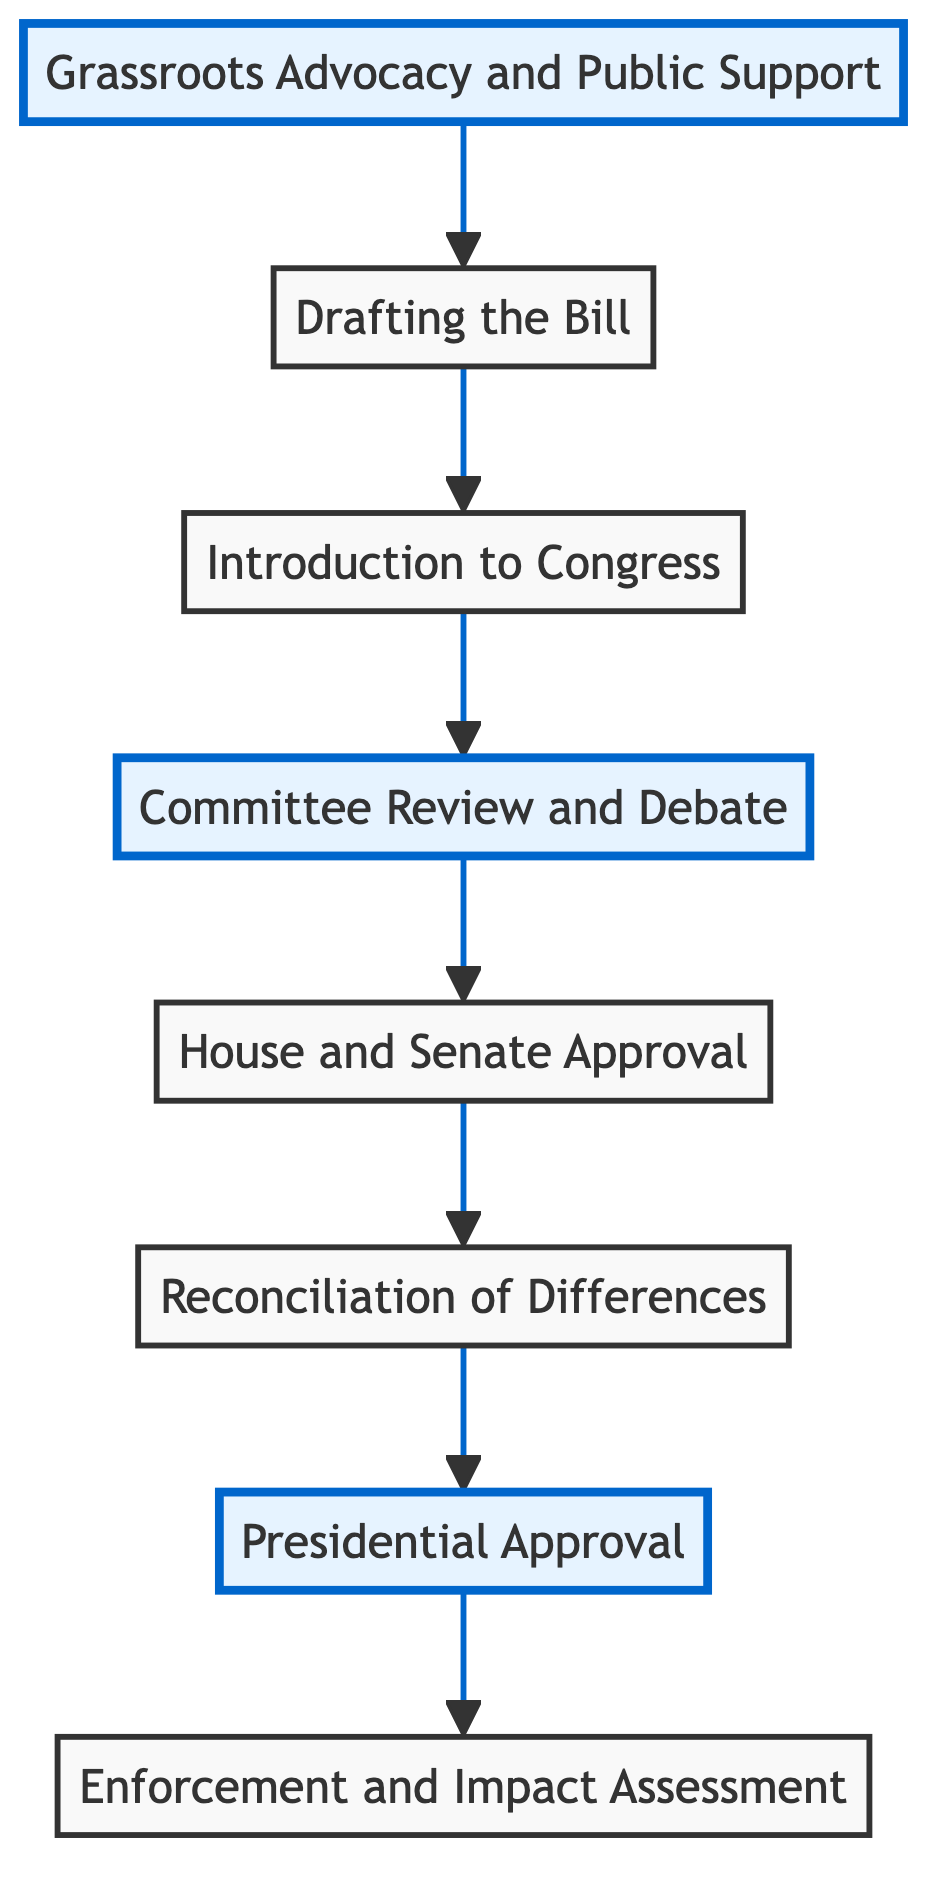What is the first step in the journey of legislation? The first step is identified as "Grassroots Advocacy and Public Support," which refers to the initial movements and efforts made by conservative groups to advocate for policy changes.
Answer: Grassroots Advocacy and Public Support Which entity drafts the proposed legislation? According to the diagram, conservative lawmakers, often influenced by think tanks, work with legal experts to draft the bill, indicating that legislators are primarily responsible for this step.
Answer: Conservative lawmakers What happens after the bill is drafted? The next step after drafting is the "Introduction to Congress," which involves a conservative member presenting the bill in either the House or Senate.
Answer: Introduction to Congress How many main steps are there in the journey of conservative legislation? Count all the steps listed in the diagram: there are eight main steps from "Grassroots Advocacy and Public Support" to "Enforcement and Impact Assessment."
Answer: Eight What is the main goal of the committee review and debate? The primary goal in the "Committee Review and Debate" stage is to review, amend, and ensure the bill aligns with conservative values through discussions among committee members.
Answer: Align the bill with conservative principles What occurs if there are differences between the House and Senate versions of the bill? The diagram states that a "conference committee is formed" to reconcile the differences, indicating a collaborative effort to reach agreement between both chambers.
Answer: Conference committee Which step concerns the President's involvement? "Presidential Approval" is the step where the reconciled bill is sent to the President for evaluation and potential signing into law, emphasizing the executive's role in the process.
Answer: Presidential Approval What follows after a bill is signed into law? Once a bill is signed, it transitions to "Enforcement and Impact Assessment," which involves execution by relevant agencies and evaluation of its effects.
Answer: Enforcement and Impact Assessment 